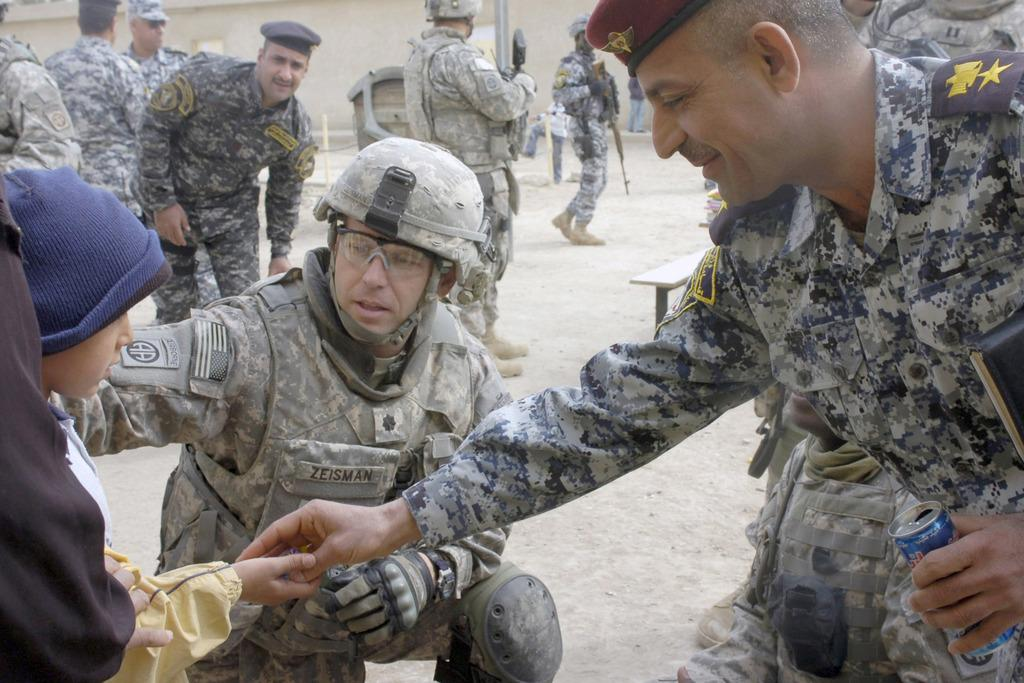What can be seen in the image regarding people? There are men standing in the image. What object is present that might be used for holding a beverage? There is a can in the image. What potentially dangerous object is visible in the image? There is a gun in the image. What protective gear is present in the image? There is a helmet in the image. What type of marble is being used to build the structure in the image? There is no structure or marble present in the image; it features men standing with a can, gun, and helmet. What type of tools might a carpenter use in the image? There is no carpenter or carpentry tools present in the image. 